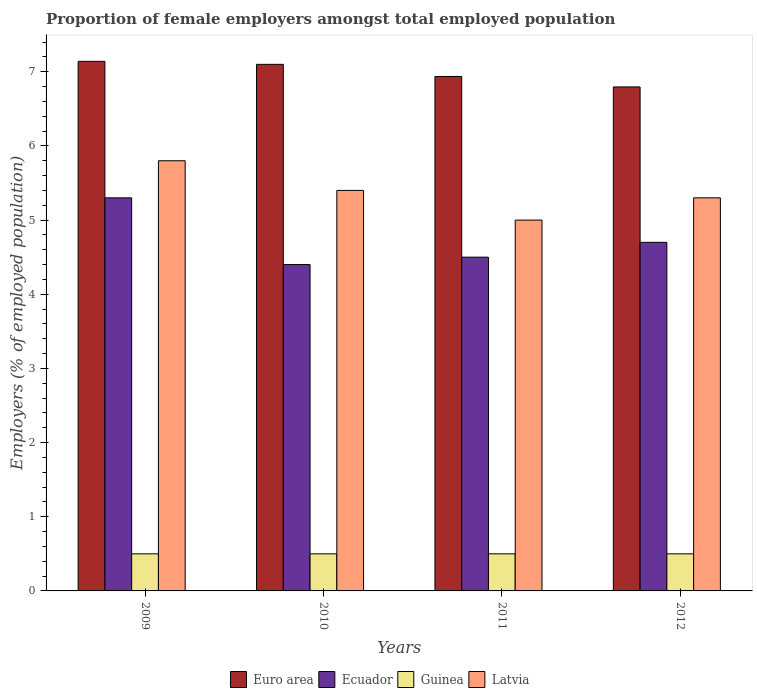How many different coloured bars are there?
Provide a short and direct response. 4. How many bars are there on the 4th tick from the right?
Offer a terse response. 4. In how many cases, is the number of bars for a given year not equal to the number of legend labels?
Ensure brevity in your answer.  0. What is the proportion of female employers in Euro area in 2010?
Make the answer very short. 7.1. Across all years, what is the maximum proportion of female employers in Ecuador?
Offer a very short reply. 5.3. Across all years, what is the minimum proportion of female employers in Euro area?
Give a very brief answer. 6.8. In which year was the proportion of female employers in Euro area minimum?
Offer a very short reply. 2012. What is the total proportion of female employers in Euro area in the graph?
Provide a short and direct response. 27.97. What is the difference between the proportion of female employers in Guinea in 2010 and that in 2012?
Ensure brevity in your answer.  0. What is the difference between the proportion of female employers in Ecuador in 2010 and the proportion of female employers in Latvia in 2012?
Your answer should be compact. -0.9. What is the average proportion of female employers in Latvia per year?
Ensure brevity in your answer.  5.38. In how many years, is the proportion of female employers in Ecuador greater than 6.2 %?
Give a very brief answer. 0. What is the ratio of the proportion of female employers in Euro area in 2009 to that in 2012?
Provide a short and direct response. 1.05. Is the proportion of female employers in Latvia in 2009 less than that in 2012?
Ensure brevity in your answer.  No. Is the difference between the proportion of female employers in Latvia in 2009 and 2010 greater than the difference between the proportion of female employers in Ecuador in 2009 and 2010?
Offer a very short reply. No. What is the difference between the highest and the second highest proportion of female employers in Latvia?
Provide a short and direct response. 0.4. What is the difference between the highest and the lowest proportion of female employers in Ecuador?
Provide a short and direct response. 0.9. In how many years, is the proportion of female employers in Ecuador greater than the average proportion of female employers in Ecuador taken over all years?
Your answer should be compact. 1. Is the sum of the proportion of female employers in Guinea in 2009 and 2010 greater than the maximum proportion of female employers in Euro area across all years?
Your answer should be compact. No. What does the 1st bar from the left in 2009 represents?
Keep it short and to the point. Euro area. What does the 1st bar from the right in 2010 represents?
Offer a terse response. Latvia. How many bars are there?
Provide a succinct answer. 16. Are all the bars in the graph horizontal?
Ensure brevity in your answer.  No. How many years are there in the graph?
Make the answer very short. 4. Are the values on the major ticks of Y-axis written in scientific E-notation?
Ensure brevity in your answer.  No. Does the graph contain grids?
Offer a terse response. No. Where does the legend appear in the graph?
Keep it short and to the point. Bottom center. How many legend labels are there?
Provide a succinct answer. 4. What is the title of the graph?
Make the answer very short. Proportion of female employers amongst total employed population. What is the label or title of the Y-axis?
Give a very brief answer. Employers (% of employed population). What is the Employers (% of employed population) of Euro area in 2009?
Provide a short and direct response. 7.14. What is the Employers (% of employed population) in Ecuador in 2009?
Offer a terse response. 5.3. What is the Employers (% of employed population) in Latvia in 2009?
Provide a short and direct response. 5.8. What is the Employers (% of employed population) in Euro area in 2010?
Offer a very short reply. 7.1. What is the Employers (% of employed population) in Ecuador in 2010?
Provide a succinct answer. 4.4. What is the Employers (% of employed population) of Guinea in 2010?
Offer a very short reply. 0.5. What is the Employers (% of employed population) of Latvia in 2010?
Give a very brief answer. 5.4. What is the Employers (% of employed population) in Euro area in 2011?
Offer a very short reply. 6.94. What is the Employers (% of employed population) of Ecuador in 2011?
Offer a terse response. 4.5. What is the Employers (% of employed population) of Latvia in 2011?
Provide a succinct answer. 5. What is the Employers (% of employed population) in Euro area in 2012?
Your answer should be very brief. 6.8. What is the Employers (% of employed population) in Ecuador in 2012?
Ensure brevity in your answer.  4.7. What is the Employers (% of employed population) in Latvia in 2012?
Give a very brief answer. 5.3. Across all years, what is the maximum Employers (% of employed population) in Euro area?
Keep it short and to the point. 7.14. Across all years, what is the maximum Employers (% of employed population) in Ecuador?
Your answer should be compact. 5.3. Across all years, what is the maximum Employers (% of employed population) in Guinea?
Offer a terse response. 0.5. Across all years, what is the maximum Employers (% of employed population) of Latvia?
Your answer should be very brief. 5.8. Across all years, what is the minimum Employers (% of employed population) in Euro area?
Give a very brief answer. 6.8. Across all years, what is the minimum Employers (% of employed population) in Ecuador?
Your response must be concise. 4.4. Across all years, what is the minimum Employers (% of employed population) in Guinea?
Your answer should be very brief. 0.5. What is the total Employers (% of employed population) in Euro area in the graph?
Give a very brief answer. 27.97. What is the total Employers (% of employed population) in Guinea in the graph?
Your answer should be very brief. 2. What is the total Employers (% of employed population) in Latvia in the graph?
Your response must be concise. 21.5. What is the difference between the Employers (% of employed population) of Euro area in 2009 and that in 2010?
Ensure brevity in your answer.  0.04. What is the difference between the Employers (% of employed population) in Ecuador in 2009 and that in 2010?
Provide a short and direct response. 0.9. What is the difference between the Employers (% of employed population) of Guinea in 2009 and that in 2010?
Your answer should be compact. 0. What is the difference between the Employers (% of employed population) in Latvia in 2009 and that in 2010?
Your response must be concise. 0.4. What is the difference between the Employers (% of employed population) in Euro area in 2009 and that in 2011?
Ensure brevity in your answer.  0.2. What is the difference between the Employers (% of employed population) in Ecuador in 2009 and that in 2011?
Provide a short and direct response. 0.8. What is the difference between the Employers (% of employed population) of Euro area in 2009 and that in 2012?
Make the answer very short. 0.34. What is the difference between the Employers (% of employed population) of Guinea in 2009 and that in 2012?
Keep it short and to the point. 0. What is the difference between the Employers (% of employed population) in Euro area in 2010 and that in 2011?
Give a very brief answer. 0.16. What is the difference between the Employers (% of employed population) of Latvia in 2010 and that in 2011?
Make the answer very short. 0.4. What is the difference between the Employers (% of employed population) in Euro area in 2010 and that in 2012?
Ensure brevity in your answer.  0.3. What is the difference between the Employers (% of employed population) in Latvia in 2010 and that in 2012?
Give a very brief answer. 0.1. What is the difference between the Employers (% of employed population) in Euro area in 2011 and that in 2012?
Give a very brief answer. 0.14. What is the difference between the Employers (% of employed population) in Latvia in 2011 and that in 2012?
Ensure brevity in your answer.  -0.3. What is the difference between the Employers (% of employed population) in Euro area in 2009 and the Employers (% of employed population) in Ecuador in 2010?
Make the answer very short. 2.74. What is the difference between the Employers (% of employed population) in Euro area in 2009 and the Employers (% of employed population) in Guinea in 2010?
Offer a terse response. 6.64. What is the difference between the Employers (% of employed population) of Euro area in 2009 and the Employers (% of employed population) of Latvia in 2010?
Offer a terse response. 1.74. What is the difference between the Employers (% of employed population) in Ecuador in 2009 and the Employers (% of employed population) in Latvia in 2010?
Your answer should be compact. -0.1. What is the difference between the Employers (% of employed population) of Guinea in 2009 and the Employers (% of employed population) of Latvia in 2010?
Offer a terse response. -4.9. What is the difference between the Employers (% of employed population) in Euro area in 2009 and the Employers (% of employed population) in Ecuador in 2011?
Ensure brevity in your answer.  2.64. What is the difference between the Employers (% of employed population) of Euro area in 2009 and the Employers (% of employed population) of Guinea in 2011?
Your answer should be compact. 6.64. What is the difference between the Employers (% of employed population) in Euro area in 2009 and the Employers (% of employed population) in Latvia in 2011?
Your response must be concise. 2.14. What is the difference between the Employers (% of employed population) of Ecuador in 2009 and the Employers (% of employed population) of Guinea in 2011?
Ensure brevity in your answer.  4.8. What is the difference between the Employers (% of employed population) in Ecuador in 2009 and the Employers (% of employed population) in Latvia in 2011?
Offer a very short reply. 0.3. What is the difference between the Employers (% of employed population) of Guinea in 2009 and the Employers (% of employed population) of Latvia in 2011?
Keep it short and to the point. -4.5. What is the difference between the Employers (% of employed population) in Euro area in 2009 and the Employers (% of employed population) in Ecuador in 2012?
Provide a short and direct response. 2.44. What is the difference between the Employers (% of employed population) of Euro area in 2009 and the Employers (% of employed population) of Guinea in 2012?
Your response must be concise. 6.64. What is the difference between the Employers (% of employed population) of Euro area in 2009 and the Employers (% of employed population) of Latvia in 2012?
Offer a terse response. 1.84. What is the difference between the Employers (% of employed population) of Guinea in 2009 and the Employers (% of employed population) of Latvia in 2012?
Provide a succinct answer. -4.8. What is the difference between the Employers (% of employed population) in Euro area in 2010 and the Employers (% of employed population) in Ecuador in 2011?
Offer a very short reply. 2.6. What is the difference between the Employers (% of employed population) of Euro area in 2010 and the Employers (% of employed population) of Guinea in 2011?
Keep it short and to the point. 6.6. What is the difference between the Employers (% of employed population) of Ecuador in 2010 and the Employers (% of employed population) of Guinea in 2011?
Offer a very short reply. 3.9. What is the difference between the Employers (% of employed population) in Euro area in 2010 and the Employers (% of employed population) in Guinea in 2012?
Provide a short and direct response. 6.6. What is the difference between the Employers (% of employed population) in Euro area in 2010 and the Employers (% of employed population) in Latvia in 2012?
Provide a succinct answer. 1.8. What is the difference between the Employers (% of employed population) in Euro area in 2011 and the Employers (% of employed population) in Ecuador in 2012?
Provide a short and direct response. 2.24. What is the difference between the Employers (% of employed population) of Euro area in 2011 and the Employers (% of employed population) of Guinea in 2012?
Provide a succinct answer. 6.44. What is the difference between the Employers (% of employed population) in Euro area in 2011 and the Employers (% of employed population) in Latvia in 2012?
Your answer should be very brief. 1.64. What is the difference between the Employers (% of employed population) of Ecuador in 2011 and the Employers (% of employed population) of Guinea in 2012?
Ensure brevity in your answer.  4. What is the difference between the Employers (% of employed population) in Guinea in 2011 and the Employers (% of employed population) in Latvia in 2012?
Offer a very short reply. -4.8. What is the average Employers (% of employed population) in Euro area per year?
Give a very brief answer. 6.99. What is the average Employers (% of employed population) in Ecuador per year?
Your answer should be very brief. 4.72. What is the average Employers (% of employed population) in Latvia per year?
Provide a succinct answer. 5.38. In the year 2009, what is the difference between the Employers (% of employed population) in Euro area and Employers (% of employed population) in Ecuador?
Make the answer very short. 1.84. In the year 2009, what is the difference between the Employers (% of employed population) in Euro area and Employers (% of employed population) in Guinea?
Offer a terse response. 6.64. In the year 2009, what is the difference between the Employers (% of employed population) in Euro area and Employers (% of employed population) in Latvia?
Your answer should be compact. 1.34. In the year 2009, what is the difference between the Employers (% of employed population) in Ecuador and Employers (% of employed population) in Latvia?
Ensure brevity in your answer.  -0.5. In the year 2010, what is the difference between the Employers (% of employed population) in Euro area and Employers (% of employed population) in Ecuador?
Give a very brief answer. 2.7. In the year 2010, what is the difference between the Employers (% of employed population) of Ecuador and Employers (% of employed population) of Guinea?
Offer a very short reply. 3.9. In the year 2010, what is the difference between the Employers (% of employed population) in Ecuador and Employers (% of employed population) in Latvia?
Your response must be concise. -1. In the year 2010, what is the difference between the Employers (% of employed population) in Guinea and Employers (% of employed population) in Latvia?
Provide a short and direct response. -4.9. In the year 2011, what is the difference between the Employers (% of employed population) in Euro area and Employers (% of employed population) in Ecuador?
Provide a succinct answer. 2.44. In the year 2011, what is the difference between the Employers (% of employed population) in Euro area and Employers (% of employed population) in Guinea?
Make the answer very short. 6.44. In the year 2011, what is the difference between the Employers (% of employed population) in Euro area and Employers (% of employed population) in Latvia?
Your answer should be very brief. 1.94. In the year 2011, what is the difference between the Employers (% of employed population) of Ecuador and Employers (% of employed population) of Guinea?
Give a very brief answer. 4. In the year 2011, what is the difference between the Employers (% of employed population) of Guinea and Employers (% of employed population) of Latvia?
Give a very brief answer. -4.5. In the year 2012, what is the difference between the Employers (% of employed population) in Euro area and Employers (% of employed population) in Ecuador?
Make the answer very short. 2.1. In the year 2012, what is the difference between the Employers (% of employed population) in Euro area and Employers (% of employed population) in Guinea?
Make the answer very short. 6.3. In the year 2012, what is the difference between the Employers (% of employed population) in Euro area and Employers (% of employed population) in Latvia?
Your response must be concise. 1.5. In the year 2012, what is the difference between the Employers (% of employed population) of Ecuador and Employers (% of employed population) of Guinea?
Provide a succinct answer. 4.2. In the year 2012, what is the difference between the Employers (% of employed population) of Guinea and Employers (% of employed population) of Latvia?
Provide a short and direct response. -4.8. What is the ratio of the Employers (% of employed population) in Euro area in 2009 to that in 2010?
Provide a succinct answer. 1.01. What is the ratio of the Employers (% of employed population) of Ecuador in 2009 to that in 2010?
Provide a short and direct response. 1.2. What is the ratio of the Employers (% of employed population) in Guinea in 2009 to that in 2010?
Keep it short and to the point. 1. What is the ratio of the Employers (% of employed population) of Latvia in 2009 to that in 2010?
Provide a short and direct response. 1.07. What is the ratio of the Employers (% of employed population) of Euro area in 2009 to that in 2011?
Give a very brief answer. 1.03. What is the ratio of the Employers (% of employed population) in Ecuador in 2009 to that in 2011?
Your answer should be very brief. 1.18. What is the ratio of the Employers (% of employed population) in Latvia in 2009 to that in 2011?
Your response must be concise. 1.16. What is the ratio of the Employers (% of employed population) in Euro area in 2009 to that in 2012?
Your answer should be compact. 1.05. What is the ratio of the Employers (% of employed population) of Ecuador in 2009 to that in 2012?
Provide a short and direct response. 1.13. What is the ratio of the Employers (% of employed population) in Guinea in 2009 to that in 2012?
Provide a short and direct response. 1. What is the ratio of the Employers (% of employed population) of Latvia in 2009 to that in 2012?
Provide a short and direct response. 1.09. What is the ratio of the Employers (% of employed population) in Euro area in 2010 to that in 2011?
Offer a terse response. 1.02. What is the ratio of the Employers (% of employed population) of Ecuador in 2010 to that in 2011?
Offer a very short reply. 0.98. What is the ratio of the Employers (% of employed population) in Euro area in 2010 to that in 2012?
Make the answer very short. 1.04. What is the ratio of the Employers (% of employed population) in Ecuador in 2010 to that in 2012?
Offer a terse response. 0.94. What is the ratio of the Employers (% of employed population) in Latvia in 2010 to that in 2012?
Provide a succinct answer. 1.02. What is the ratio of the Employers (% of employed population) of Euro area in 2011 to that in 2012?
Your response must be concise. 1.02. What is the ratio of the Employers (% of employed population) of Ecuador in 2011 to that in 2012?
Make the answer very short. 0.96. What is the ratio of the Employers (% of employed population) of Latvia in 2011 to that in 2012?
Your answer should be very brief. 0.94. What is the difference between the highest and the second highest Employers (% of employed population) of Euro area?
Keep it short and to the point. 0.04. What is the difference between the highest and the second highest Employers (% of employed population) in Ecuador?
Provide a succinct answer. 0.6. What is the difference between the highest and the second highest Employers (% of employed population) of Guinea?
Your response must be concise. 0. What is the difference between the highest and the second highest Employers (% of employed population) of Latvia?
Offer a very short reply. 0.4. What is the difference between the highest and the lowest Employers (% of employed population) in Euro area?
Make the answer very short. 0.34. What is the difference between the highest and the lowest Employers (% of employed population) of Guinea?
Make the answer very short. 0. What is the difference between the highest and the lowest Employers (% of employed population) of Latvia?
Make the answer very short. 0.8. 